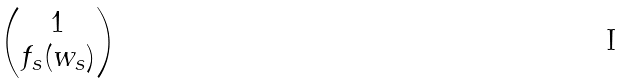Convert formula to latex. <formula><loc_0><loc_0><loc_500><loc_500>\begin{pmatrix} 1 \\ f _ { s } ( w _ { s } ) \end{pmatrix}</formula> 